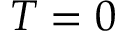<formula> <loc_0><loc_0><loc_500><loc_500>T = 0</formula> 